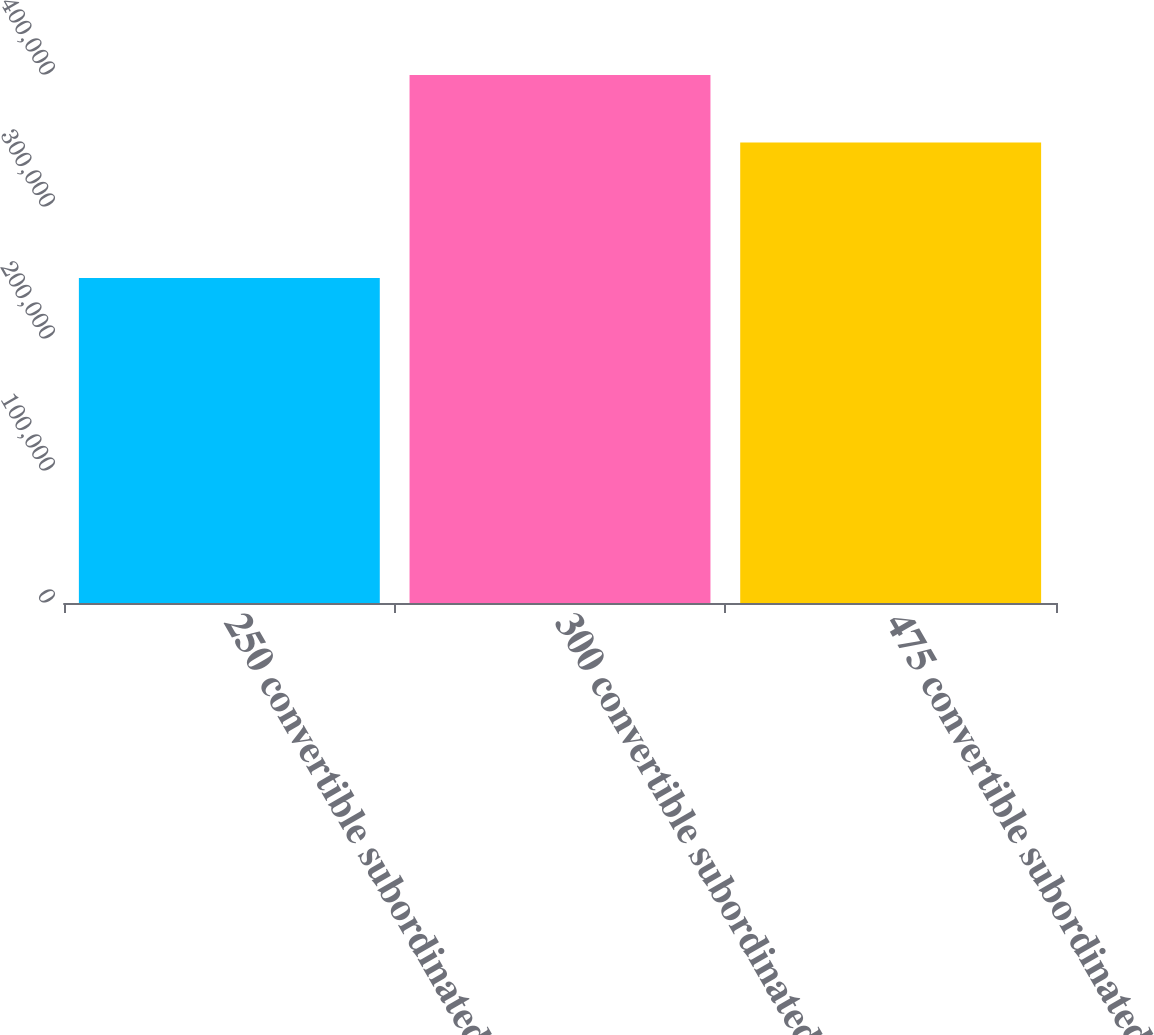Convert chart to OTSL. <chart><loc_0><loc_0><loc_500><loc_500><bar_chart><fcel>250 convertible subordinated<fcel>300 convertible subordinated<fcel>475 convertible subordinated<nl><fcel>246280<fcel>399946<fcel>348786<nl></chart> 